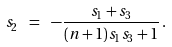Convert formula to latex. <formula><loc_0><loc_0><loc_500><loc_500>s _ { 2 } \ = \ - \frac { s _ { 1 } + s _ { 3 } } { ( n + 1 ) s _ { 1 } s _ { 3 } + 1 } \, .</formula> 